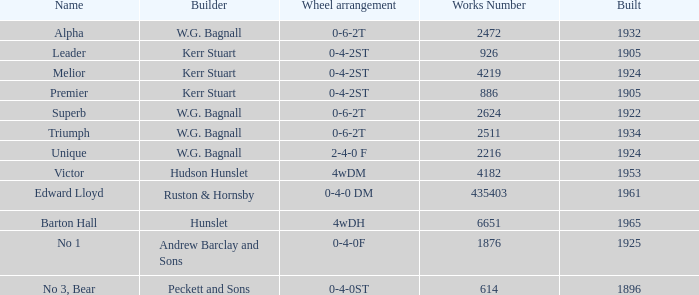What is the work number for Victor? 4182.0. 